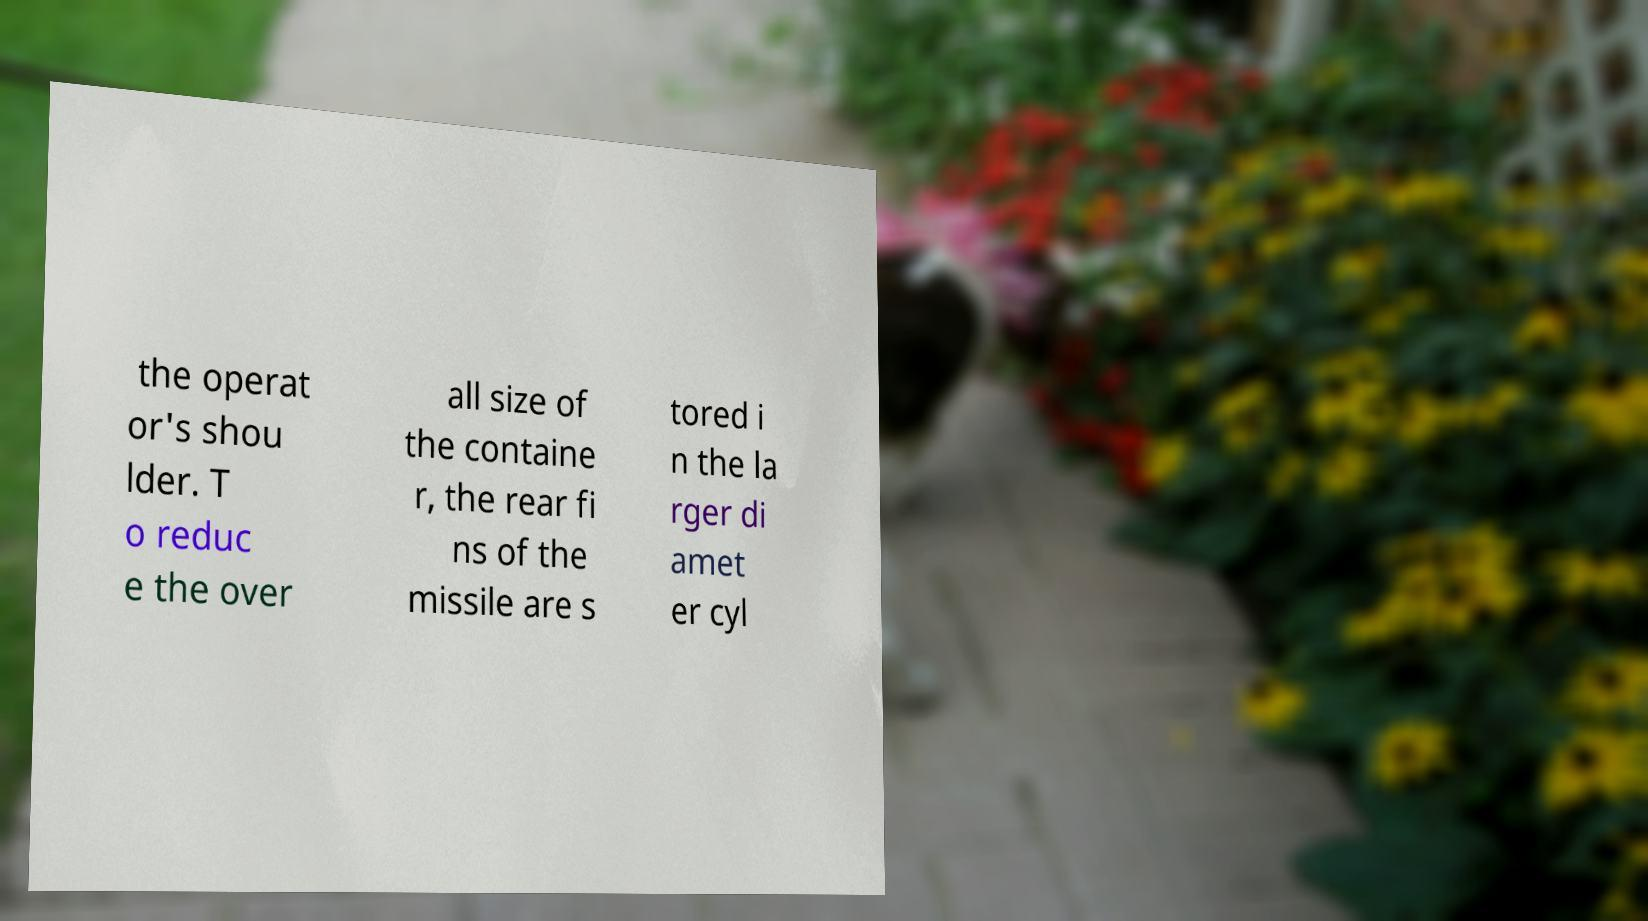Can you read and provide the text displayed in the image?This photo seems to have some interesting text. Can you extract and type it out for me? the operat or's shou lder. T o reduc e the over all size of the containe r, the rear fi ns of the missile are s tored i n the la rger di amet er cyl 